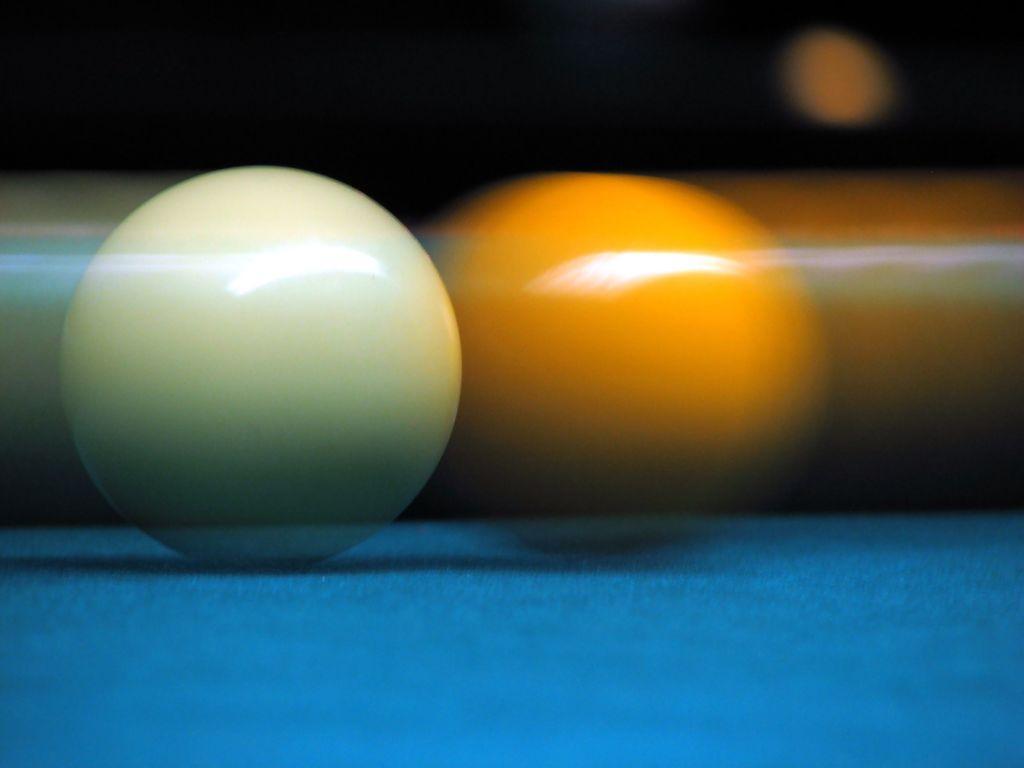In one or two sentences, can you explain what this image depicts? In this image, on the left side, we can see a ball which is in white color. In the middle of the image, we can also see another ball which is in orange color. At the bottom, we can see blue color, at the top, we can see black color. On the right side, we can see blur image. 